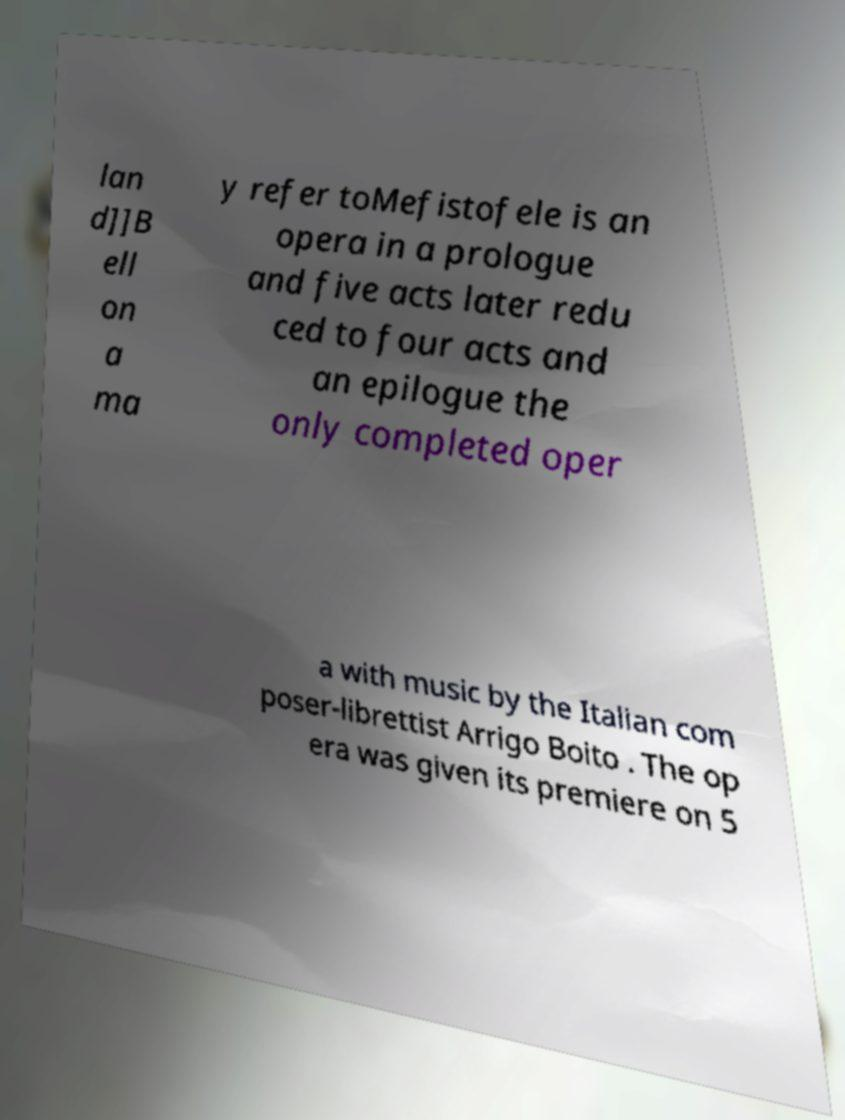Please read and relay the text visible in this image. What does it say? lan d]]B ell on a ma y refer toMefistofele is an opera in a prologue and five acts later redu ced to four acts and an epilogue the only completed oper a with music by the Italian com poser-librettist Arrigo Boito . The op era was given its premiere on 5 